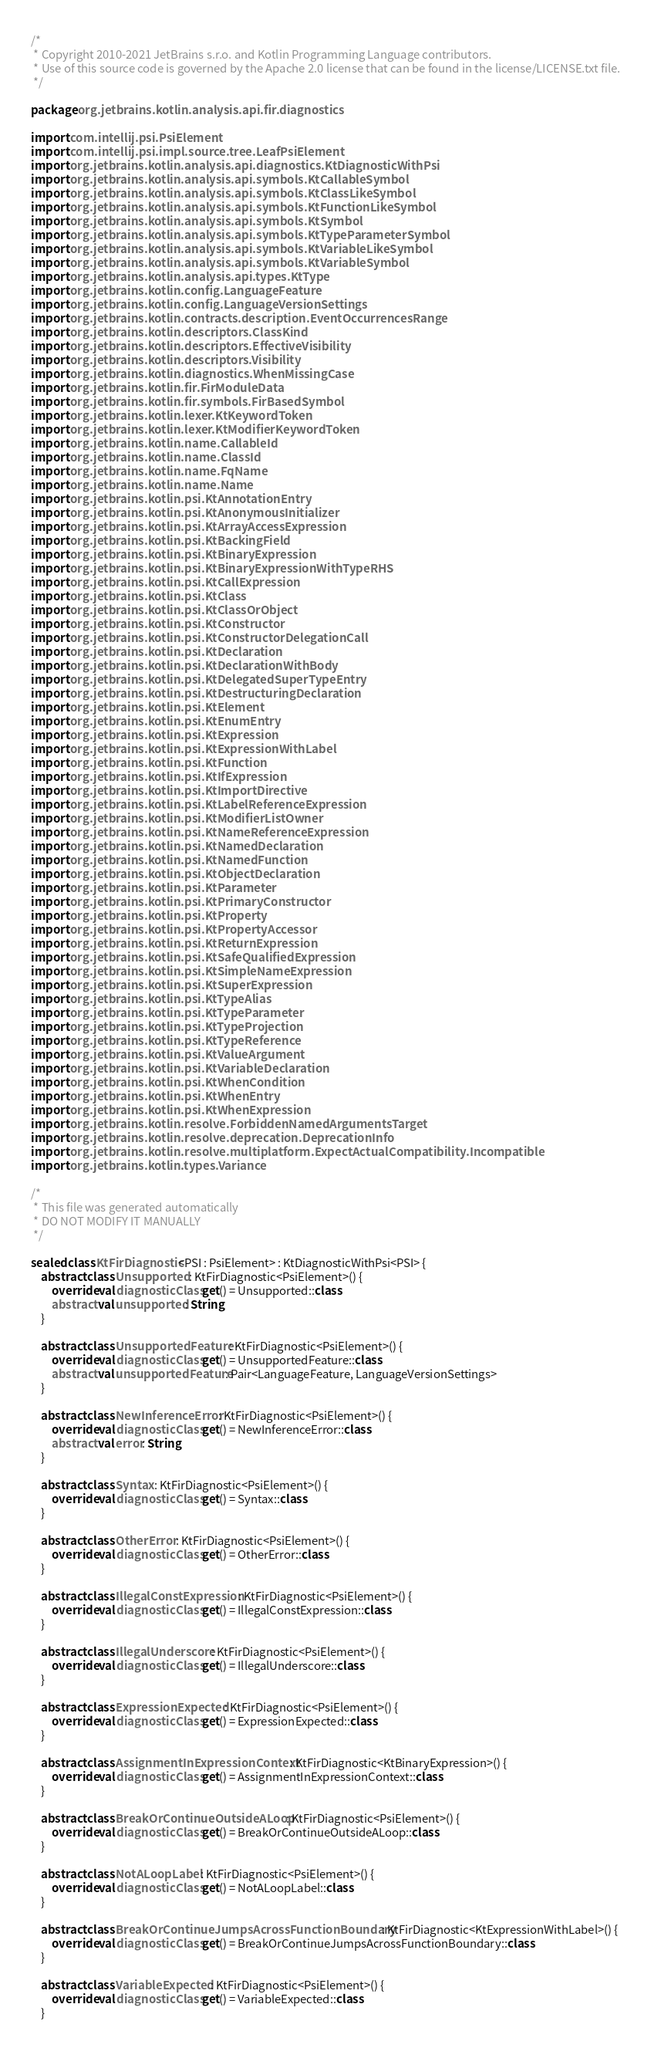Convert code to text. <code><loc_0><loc_0><loc_500><loc_500><_Kotlin_>/*
 * Copyright 2010-2021 JetBrains s.r.o. and Kotlin Programming Language contributors.
 * Use of this source code is governed by the Apache 2.0 license that can be found in the license/LICENSE.txt file.
 */

package org.jetbrains.kotlin.analysis.api.fir.diagnostics

import com.intellij.psi.PsiElement
import com.intellij.psi.impl.source.tree.LeafPsiElement
import org.jetbrains.kotlin.analysis.api.diagnostics.KtDiagnosticWithPsi
import org.jetbrains.kotlin.analysis.api.symbols.KtCallableSymbol
import org.jetbrains.kotlin.analysis.api.symbols.KtClassLikeSymbol
import org.jetbrains.kotlin.analysis.api.symbols.KtFunctionLikeSymbol
import org.jetbrains.kotlin.analysis.api.symbols.KtSymbol
import org.jetbrains.kotlin.analysis.api.symbols.KtTypeParameterSymbol
import org.jetbrains.kotlin.analysis.api.symbols.KtVariableLikeSymbol
import org.jetbrains.kotlin.analysis.api.symbols.KtVariableSymbol
import org.jetbrains.kotlin.analysis.api.types.KtType
import org.jetbrains.kotlin.config.LanguageFeature
import org.jetbrains.kotlin.config.LanguageVersionSettings
import org.jetbrains.kotlin.contracts.description.EventOccurrencesRange
import org.jetbrains.kotlin.descriptors.ClassKind
import org.jetbrains.kotlin.descriptors.EffectiveVisibility
import org.jetbrains.kotlin.descriptors.Visibility
import org.jetbrains.kotlin.diagnostics.WhenMissingCase
import org.jetbrains.kotlin.fir.FirModuleData
import org.jetbrains.kotlin.fir.symbols.FirBasedSymbol
import org.jetbrains.kotlin.lexer.KtKeywordToken
import org.jetbrains.kotlin.lexer.KtModifierKeywordToken
import org.jetbrains.kotlin.name.CallableId
import org.jetbrains.kotlin.name.ClassId
import org.jetbrains.kotlin.name.FqName
import org.jetbrains.kotlin.name.Name
import org.jetbrains.kotlin.psi.KtAnnotationEntry
import org.jetbrains.kotlin.psi.KtAnonymousInitializer
import org.jetbrains.kotlin.psi.KtArrayAccessExpression
import org.jetbrains.kotlin.psi.KtBackingField
import org.jetbrains.kotlin.psi.KtBinaryExpression
import org.jetbrains.kotlin.psi.KtBinaryExpressionWithTypeRHS
import org.jetbrains.kotlin.psi.KtCallExpression
import org.jetbrains.kotlin.psi.KtClass
import org.jetbrains.kotlin.psi.KtClassOrObject
import org.jetbrains.kotlin.psi.KtConstructor
import org.jetbrains.kotlin.psi.KtConstructorDelegationCall
import org.jetbrains.kotlin.psi.KtDeclaration
import org.jetbrains.kotlin.psi.KtDeclarationWithBody
import org.jetbrains.kotlin.psi.KtDelegatedSuperTypeEntry
import org.jetbrains.kotlin.psi.KtDestructuringDeclaration
import org.jetbrains.kotlin.psi.KtElement
import org.jetbrains.kotlin.psi.KtEnumEntry
import org.jetbrains.kotlin.psi.KtExpression
import org.jetbrains.kotlin.psi.KtExpressionWithLabel
import org.jetbrains.kotlin.psi.KtFunction
import org.jetbrains.kotlin.psi.KtIfExpression
import org.jetbrains.kotlin.psi.KtImportDirective
import org.jetbrains.kotlin.psi.KtLabelReferenceExpression
import org.jetbrains.kotlin.psi.KtModifierListOwner
import org.jetbrains.kotlin.psi.KtNameReferenceExpression
import org.jetbrains.kotlin.psi.KtNamedDeclaration
import org.jetbrains.kotlin.psi.KtNamedFunction
import org.jetbrains.kotlin.psi.KtObjectDeclaration
import org.jetbrains.kotlin.psi.KtParameter
import org.jetbrains.kotlin.psi.KtPrimaryConstructor
import org.jetbrains.kotlin.psi.KtProperty
import org.jetbrains.kotlin.psi.KtPropertyAccessor
import org.jetbrains.kotlin.psi.KtReturnExpression
import org.jetbrains.kotlin.psi.KtSafeQualifiedExpression
import org.jetbrains.kotlin.psi.KtSimpleNameExpression
import org.jetbrains.kotlin.psi.KtSuperExpression
import org.jetbrains.kotlin.psi.KtTypeAlias
import org.jetbrains.kotlin.psi.KtTypeParameter
import org.jetbrains.kotlin.psi.KtTypeProjection
import org.jetbrains.kotlin.psi.KtTypeReference
import org.jetbrains.kotlin.psi.KtValueArgument
import org.jetbrains.kotlin.psi.KtVariableDeclaration
import org.jetbrains.kotlin.psi.KtWhenCondition
import org.jetbrains.kotlin.psi.KtWhenEntry
import org.jetbrains.kotlin.psi.KtWhenExpression
import org.jetbrains.kotlin.resolve.ForbiddenNamedArgumentsTarget
import org.jetbrains.kotlin.resolve.deprecation.DeprecationInfo
import org.jetbrains.kotlin.resolve.multiplatform.ExpectActualCompatibility.Incompatible
import org.jetbrains.kotlin.types.Variance

/*
 * This file was generated automatically
 * DO NOT MODIFY IT MANUALLY
 */

sealed class KtFirDiagnostic<PSI : PsiElement> : KtDiagnosticWithPsi<PSI> {
    abstract class Unsupported : KtFirDiagnostic<PsiElement>() {
        override val diagnosticClass get() = Unsupported::class
        abstract val unsupported: String
    }

    abstract class UnsupportedFeature : KtFirDiagnostic<PsiElement>() {
        override val diagnosticClass get() = UnsupportedFeature::class
        abstract val unsupportedFeature: Pair<LanguageFeature, LanguageVersionSettings>
    }

    abstract class NewInferenceError : KtFirDiagnostic<PsiElement>() {
        override val diagnosticClass get() = NewInferenceError::class
        abstract val error: String
    }

    abstract class Syntax : KtFirDiagnostic<PsiElement>() {
        override val diagnosticClass get() = Syntax::class
    }

    abstract class OtherError : KtFirDiagnostic<PsiElement>() {
        override val diagnosticClass get() = OtherError::class
    }

    abstract class IllegalConstExpression : KtFirDiagnostic<PsiElement>() {
        override val diagnosticClass get() = IllegalConstExpression::class
    }

    abstract class IllegalUnderscore : KtFirDiagnostic<PsiElement>() {
        override val diagnosticClass get() = IllegalUnderscore::class
    }

    abstract class ExpressionExpected : KtFirDiagnostic<PsiElement>() {
        override val diagnosticClass get() = ExpressionExpected::class
    }

    abstract class AssignmentInExpressionContext : KtFirDiagnostic<KtBinaryExpression>() {
        override val diagnosticClass get() = AssignmentInExpressionContext::class
    }

    abstract class BreakOrContinueOutsideALoop : KtFirDiagnostic<PsiElement>() {
        override val diagnosticClass get() = BreakOrContinueOutsideALoop::class
    }

    abstract class NotALoopLabel : KtFirDiagnostic<PsiElement>() {
        override val diagnosticClass get() = NotALoopLabel::class
    }

    abstract class BreakOrContinueJumpsAcrossFunctionBoundary : KtFirDiagnostic<KtExpressionWithLabel>() {
        override val diagnosticClass get() = BreakOrContinueJumpsAcrossFunctionBoundary::class
    }

    abstract class VariableExpected : KtFirDiagnostic<PsiElement>() {
        override val diagnosticClass get() = VariableExpected::class
    }
</code> 